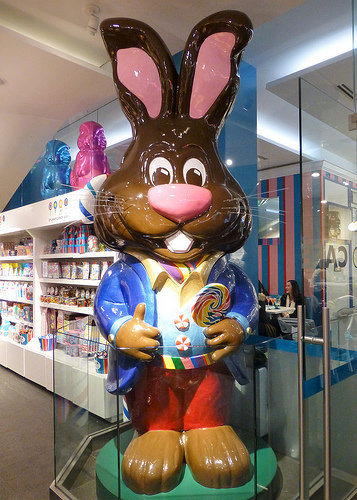<image>
Is there a toy under the shelf? No. The toy is not positioned under the shelf. The vertical relationship between these objects is different. Is the woman to the right of the bunny? Yes. From this viewpoint, the woman is positioned to the right side relative to the bunny. 